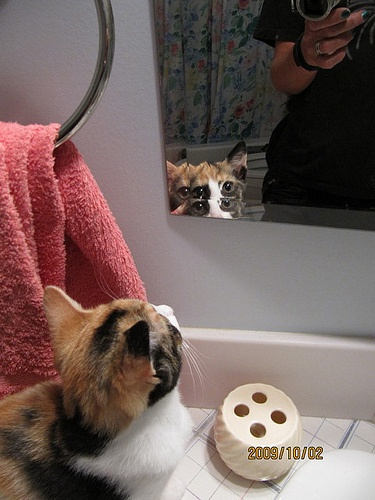Describe the objects in this image and their specific colors. I can see cat in gray, black, and maroon tones, people in gray, black, and maroon tones, and sink in gray, lightgray, and darkgray tones in this image. 